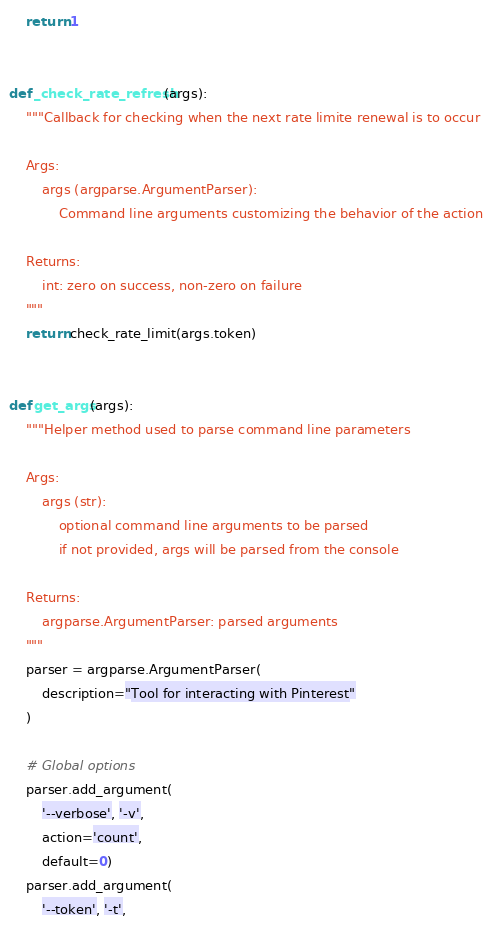Convert code to text. <code><loc_0><loc_0><loc_500><loc_500><_Python_>    return 1


def _check_rate_refresh(args):
    """Callback for checking when the next rate limite renewal is to occur

    Args:
        args (argparse.ArgumentParser):
            Command line arguments customizing the behavior of the action

    Returns:
        int: zero on success, non-zero on failure
    """
    return check_rate_limit(args.token)


def get_args(args):
    """Helper method used to parse command line parameters

    Args:
        args (str):
            optional command line arguments to be parsed
            if not provided, args will be parsed from the console

    Returns:
        argparse.ArgumentParser: parsed arguments
    """
    parser = argparse.ArgumentParser(
        description="Tool for interacting with Pinterest"
    )

    # Global options
    parser.add_argument(
        '--verbose', '-v',
        action='count',
        default=0)
    parser.add_argument(
        '--token', '-t',</code> 